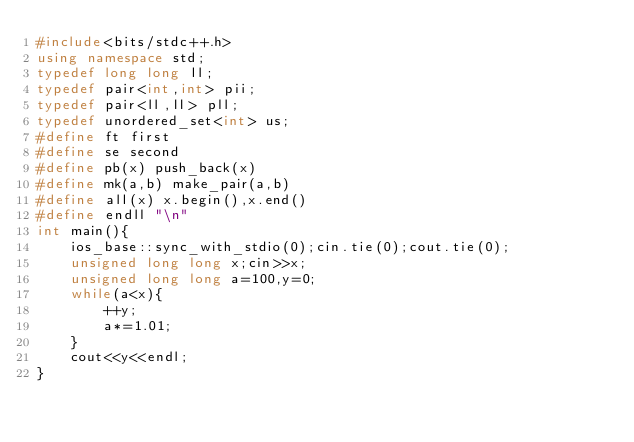<code> <loc_0><loc_0><loc_500><loc_500><_C++_>#include<bits/stdc++.h>
using namespace std;
typedef long long ll;
typedef pair<int,int> pii;
typedef pair<ll,ll> pll;
typedef unordered_set<int> us;
#define ft first
#define se second
#define pb(x) push_back(x)
#define mk(a,b) make_pair(a,b)
#define all(x) x.begin(),x.end()
#define endll "\n"
int main(){
    ios_base::sync_with_stdio(0);cin.tie(0);cout.tie(0);
    unsigned long long x;cin>>x;
    unsigned long long a=100,y=0;
    while(a<x){
        ++y;
        a*=1.01;
    }
    cout<<y<<endl;
}
</code> 